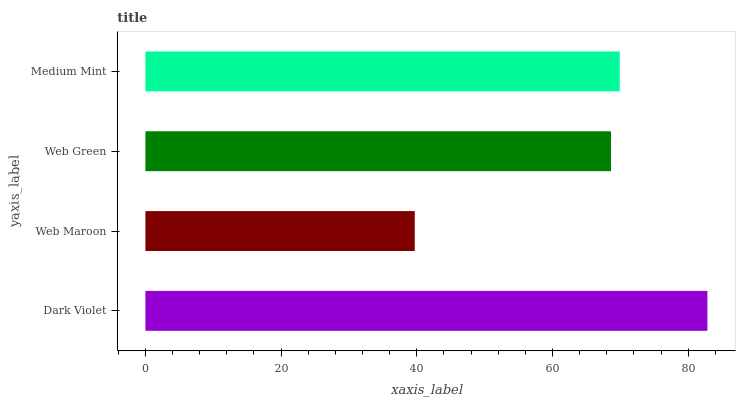Is Web Maroon the minimum?
Answer yes or no. Yes. Is Dark Violet the maximum?
Answer yes or no. Yes. Is Web Green the minimum?
Answer yes or no. No. Is Web Green the maximum?
Answer yes or no. No. Is Web Green greater than Web Maroon?
Answer yes or no. Yes. Is Web Maroon less than Web Green?
Answer yes or no. Yes. Is Web Maroon greater than Web Green?
Answer yes or no. No. Is Web Green less than Web Maroon?
Answer yes or no. No. Is Medium Mint the high median?
Answer yes or no. Yes. Is Web Green the low median?
Answer yes or no. Yes. Is Dark Violet the high median?
Answer yes or no. No. Is Medium Mint the low median?
Answer yes or no. No. 